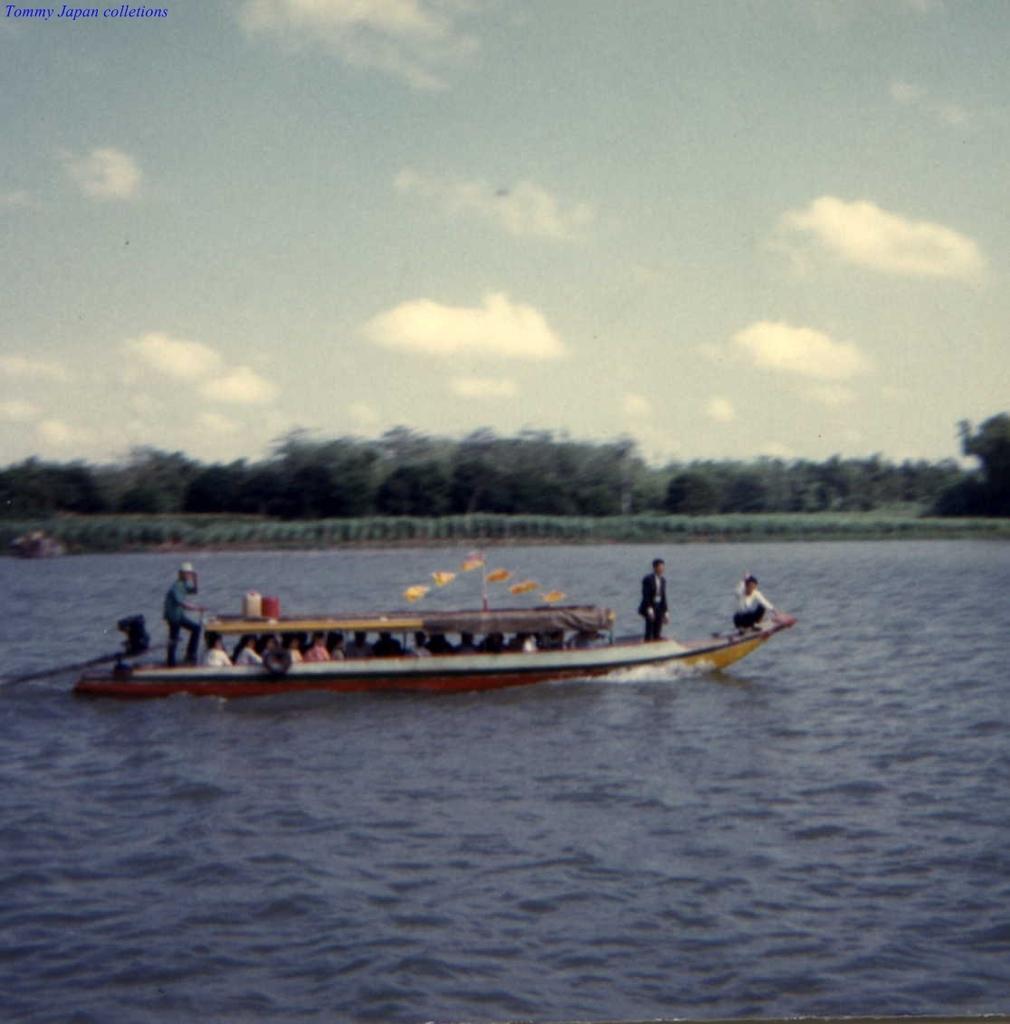Describe this image in one or two sentences. In this image there is a boat on the lake, in which there are few people visible and there are some objects on the boat, in the middle there are some trees, at the top there is the sky. 